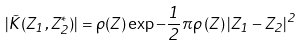Convert formula to latex. <formula><loc_0><loc_0><loc_500><loc_500>| \tilde { K } ( Z _ { 1 } , Z _ { 2 } ^ { * } ) | = \rho ( Z ) \exp { - \frac { 1 } { 2 } \pi \rho \left ( Z \right ) | Z _ { 1 } - Z _ { 2 } | ^ { 2 } }</formula> 